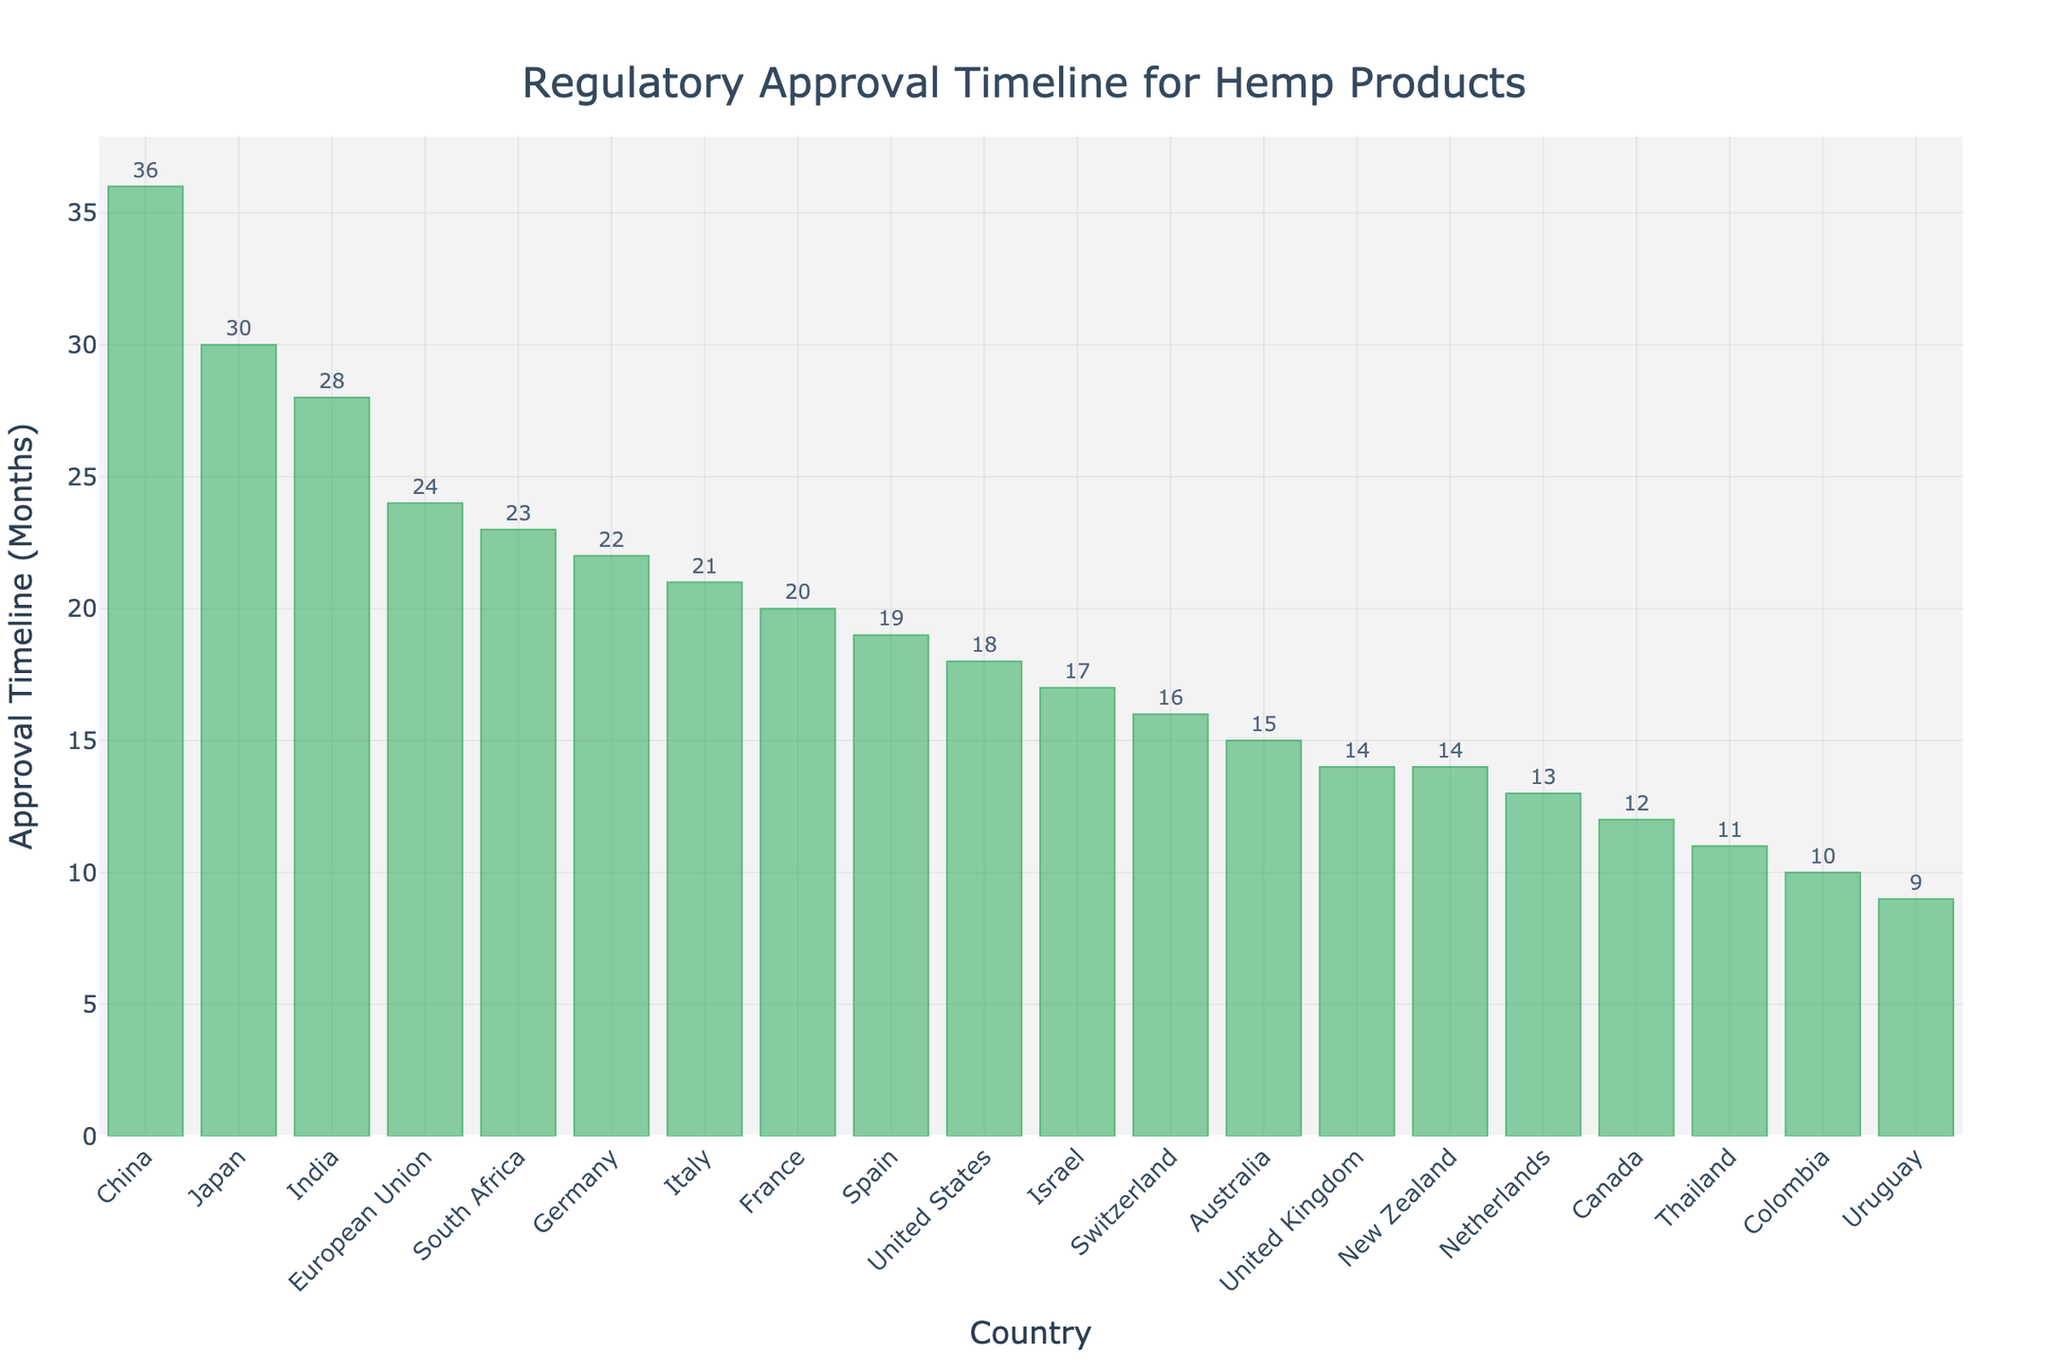What country has the longest regulatory approval timeline for hemp products? The bar corresponding to China is the tallest, indicating it has the highest approval timeline.
Answer: China Which country has the shortest regulatory approval timeline for hemp products? The bar corresponding to Uruguay is the shortest, indicating it has the lowest approval timeline.
Answer: Uruguay How much longer is the regulatory approval timeline in Japan compared to Colombia? Japan has a timeline of 30 months and Colombia has a timeline of 10 months. The difference is 30 - 10 = 20 months.
Answer: 20 months What is the average approval timeline for the countries listed? Sum up all the timelines and divide by the number of countries: (18+12+24+15+14+30+22+20+16+13+21+19+17+10+9+36+28+11+14+23)/20. The sum is 352, so the average is 352/20 = 17.6 months.
Answer: 17.6 months How many countries have an approval timeline greater than 20 months? Identify bars taller than the 20-month mark: EU (24 months), Japan (30 months), Germany (22 months), France (20 months exactly), China (36 months), India (28 months), South Africa (23 months). There are 7 such countries.
Answer: 7 countries Which country has a similar approval timeline to New Zealand? New Zealand has an approval timeline of 14 months. The United Kingdom also has an approval timeline of 14 months, as indicated by the height of their corresponding bars.
Answer: United Kingdom What is the difference in approval timeline between the country with the shortest and the country with the longest timelines? The shortest timeline is Uruguay with 9 months, and the longest is China with 36 months. The difference is 36 - 9 = 27 months.
Answer: 27 months Is the regulatory approval timeline in the United States longer than in Canada? Yes, the height of the bar for the United States (18 months) is greater than that for Canada (12 months).
Answer: Yes What is the total approval timeline for the European Union and Germany combined? The European Union has an approval timeline of 24 months, and Germany has a timeline of 22 months. The total is 24 + 22 = 46 months.
Answer: 46 months Find the median approval timeline of the countries listed. The sorted timelines are: 9, 10, 11, 12, 13, 14, 14, 15, 16, 17, 18, 19, 20, 21, 22, 23, 24, 28, 30, 36. The median is the average of the 10th and 11th values (17 and 18). So, (17 + 18) / 2 = 17.5 months.
Answer: 17.5 months 